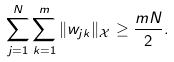<formula> <loc_0><loc_0><loc_500><loc_500>\sum _ { j = 1 } ^ { N } \sum _ { k = 1 } ^ { m } \| w _ { j k } \| _ { \mathcal { X } } \geq \frac { m N } { 2 } .</formula> 